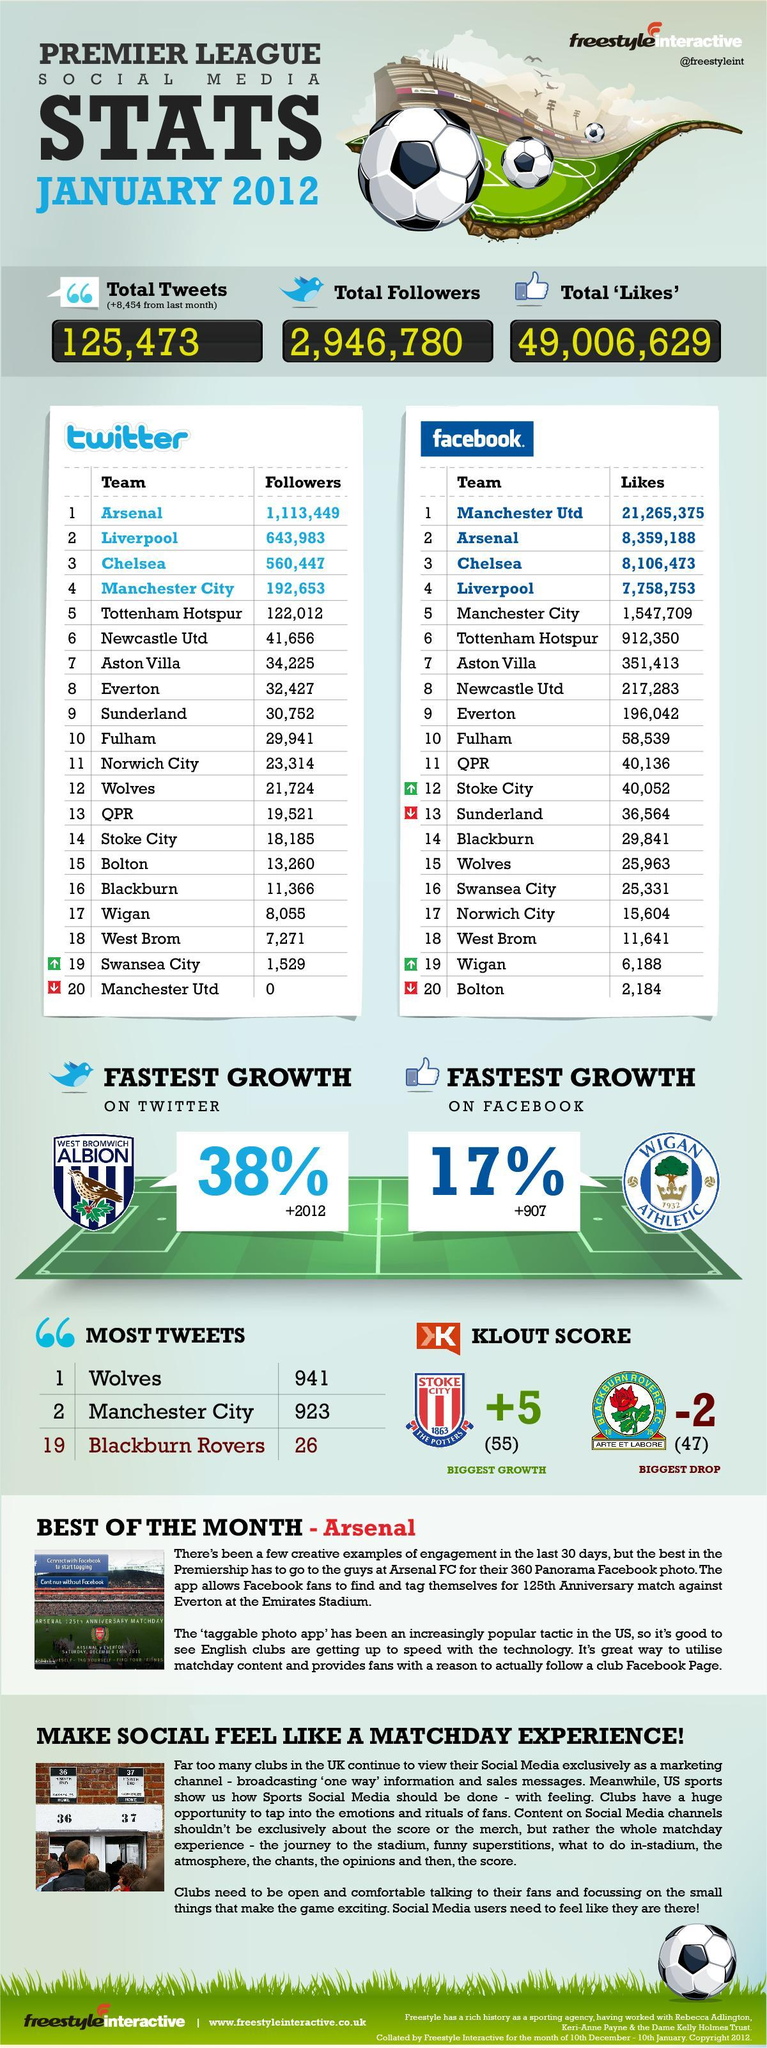Which football club most number of likes on Facebook and but no followers in Twitter?
Answer the question with a short phrase. Manchester Utd Which football team is fourth in number of followers and the fifth in number of likes? Manchester City 